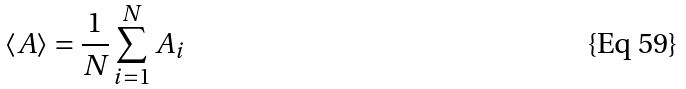Convert formula to latex. <formula><loc_0><loc_0><loc_500><loc_500>\left \langle A \right \rangle = \frac { 1 } { N } \sum _ { i = 1 } ^ { N } A _ { i }</formula> 